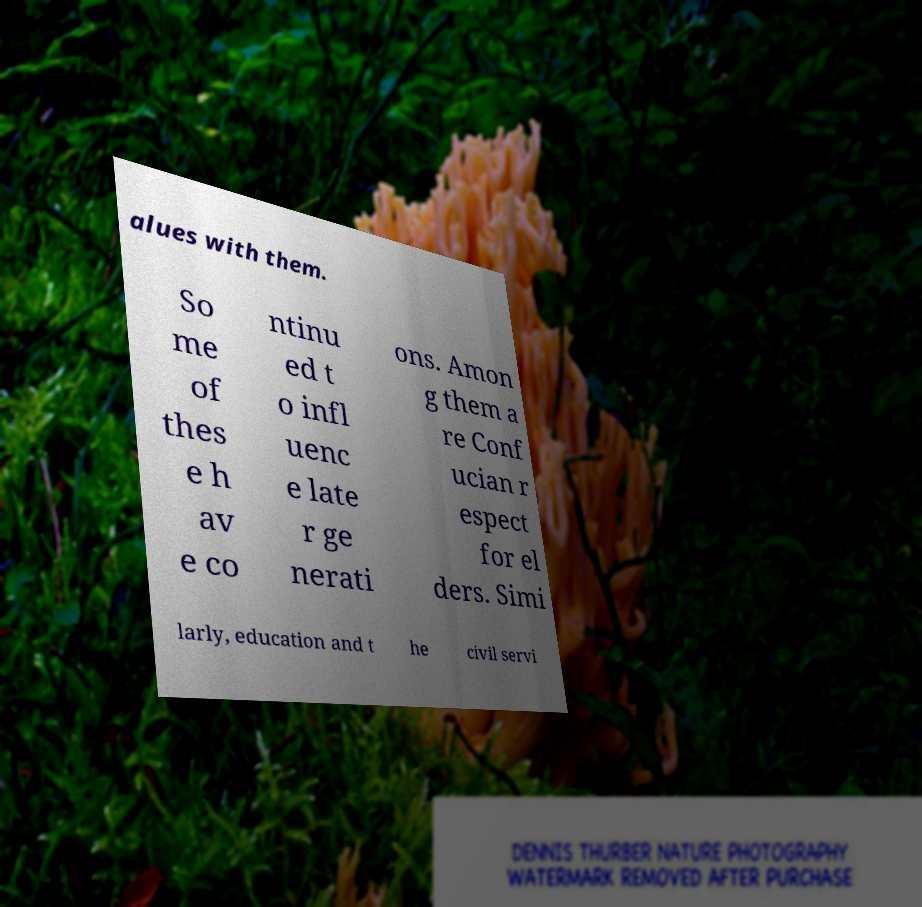There's text embedded in this image that I need extracted. Can you transcribe it verbatim? alues with them. So me of thes e h av e co ntinu ed t o infl uenc e late r ge nerati ons. Amon g them a re Conf ucian r espect for el ders. Simi larly, education and t he civil servi 